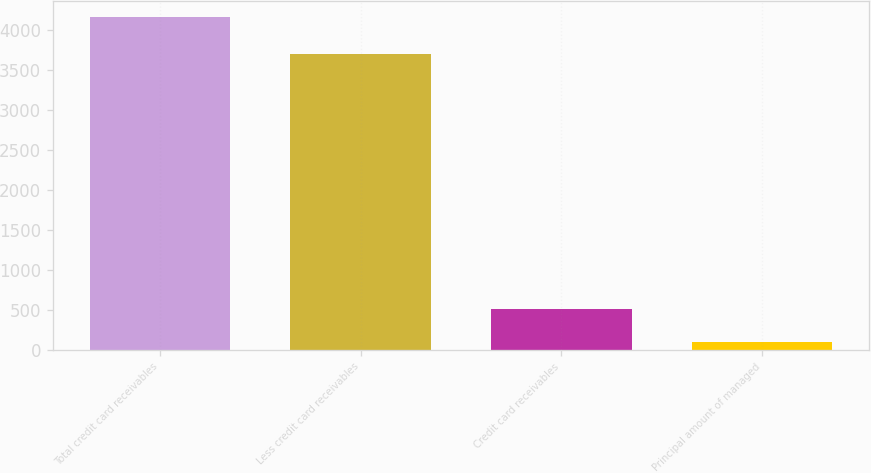Convert chart to OTSL. <chart><loc_0><loc_0><loc_500><loc_500><bar_chart><fcel>Total credit card receivables<fcel>Less credit card receivables<fcel>Credit card receivables<fcel>Principal amount of managed<nl><fcel>4157.3<fcel>3705.4<fcel>507.44<fcel>101.9<nl></chart> 